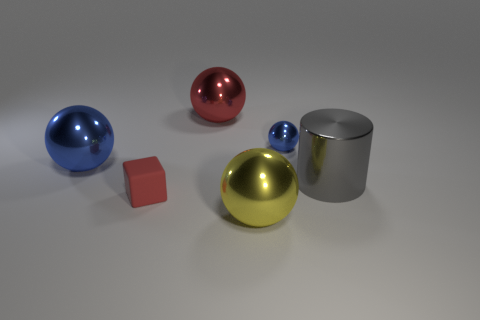Can you describe the reflection visible on the closest blue ball? Certainly! The reflection on the closest blue ball appears to show soft lighting, which indicates that the environment around these objects is probably diffuse and evenly lit. There's no distinct reflection of other objects or the room, suggesting a simple, non-detailed environment in the rendering. 